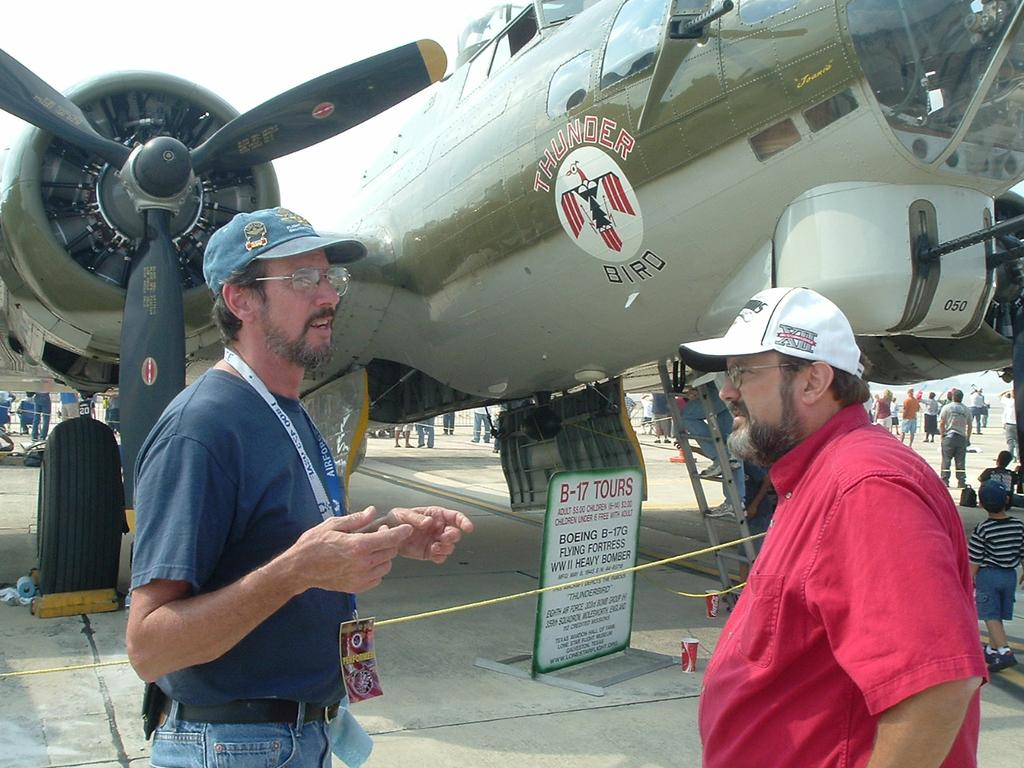Provide a one-sentence caption for the provided image. Two middle aged men stand in front of the Thunder Bird Airplane talking. 